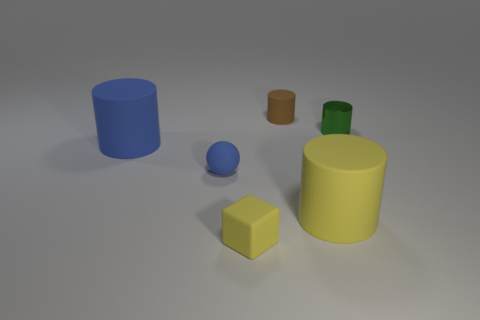How many other objects are there of the same shape as the brown rubber object?
Offer a very short reply. 3. What number of metallic objects are tiny gray things or large yellow cylinders?
Offer a terse response. 0. What is the material of the tiny cylinder to the right of the tiny thing behind the metal object?
Ensure brevity in your answer.  Metal. Are there more large blue matte objects that are in front of the rubber sphere than small blue things?
Make the answer very short. No. Is there a large thing made of the same material as the tiny yellow object?
Give a very brief answer. Yes. Does the large matte thing on the left side of the small brown rubber object have the same shape as the small blue rubber thing?
Keep it short and to the point. No. There is a matte object that is behind the metal cylinder to the right of the small rubber cube; what number of cylinders are right of it?
Give a very brief answer. 2. Are there fewer small green cylinders that are left of the metallic cylinder than blue things that are on the right side of the blue cylinder?
Your answer should be compact. Yes. There is a tiny shiny thing that is the same shape as the big blue object; what is its color?
Offer a terse response. Green. The blue cylinder has what size?
Your response must be concise. Large. 